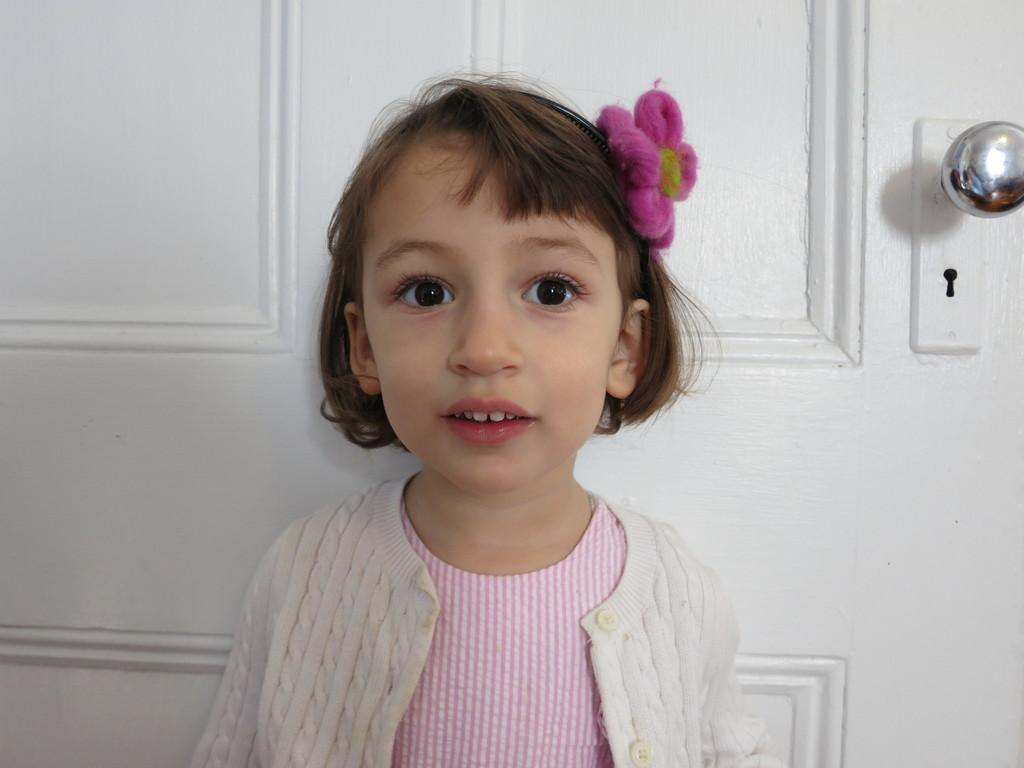What part of a door can be seen in the background of the image? There is a partial part of a door visible in the background. What feature of a door is present in the image? There is a door knob in the image. Who is in the image? There is a girl in the image. What is the girl wearing? The girl is wearing a sweater. What is the chance of the girl bleeding from a gunshot wound in the image? There is no indication of a gunshot wound or any blood in the image, so it is not possible to determine the chance of the girl bleeding. 